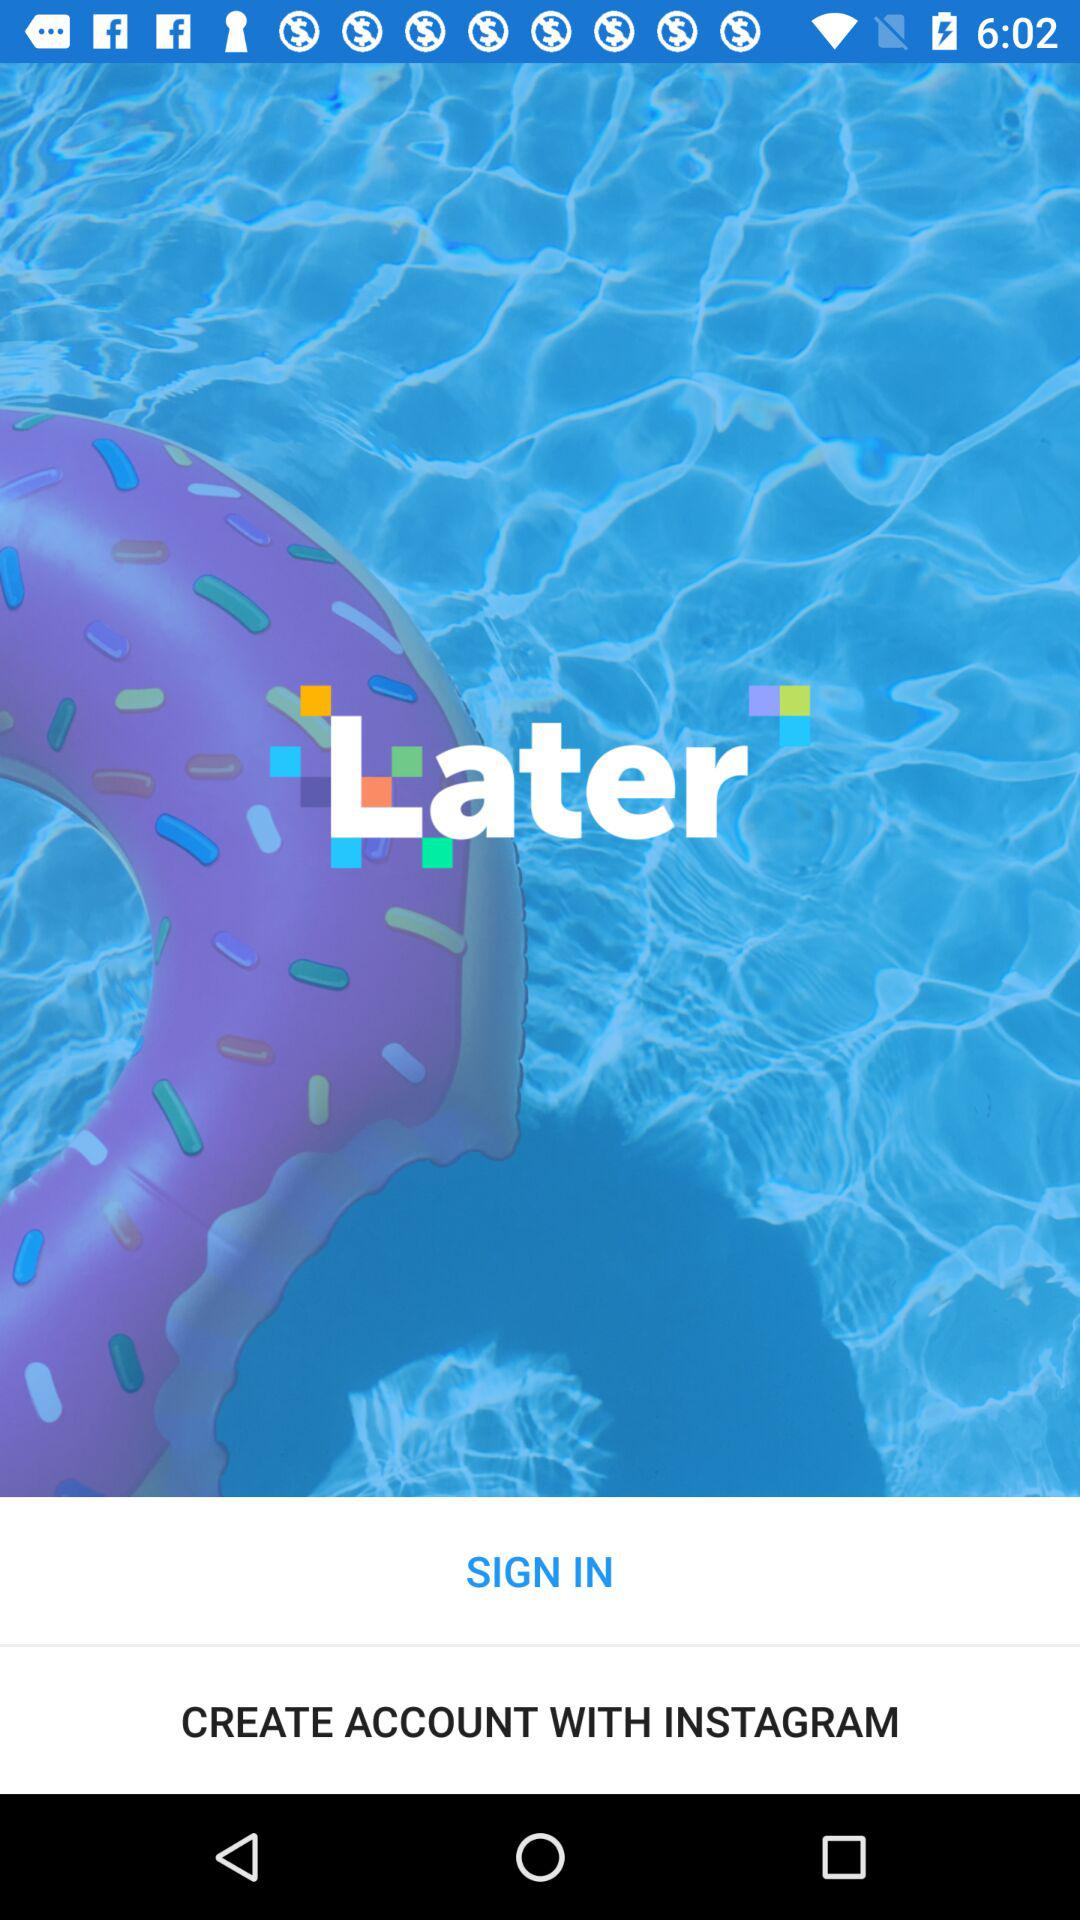What is the name of the application? The name of the application is "Later". 